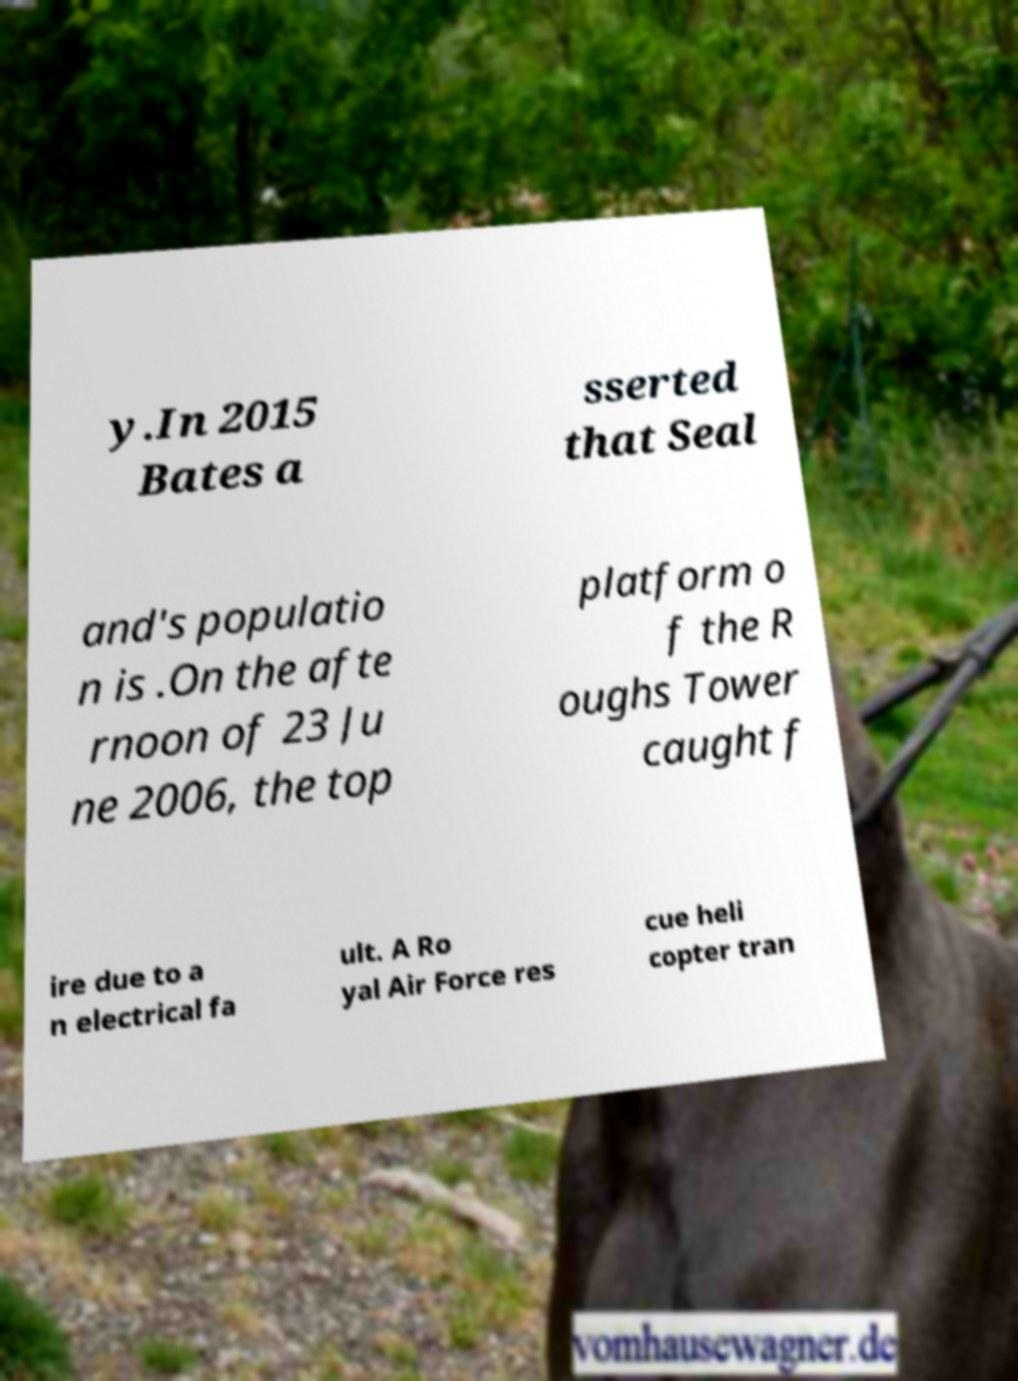For documentation purposes, I need the text within this image transcribed. Could you provide that? y.In 2015 Bates a sserted that Seal and's populatio n is .On the afte rnoon of 23 Ju ne 2006, the top platform o f the R oughs Tower caught f ire due to a n electrical fa ult. A Ro yal Air Force res cue heli copter tran 